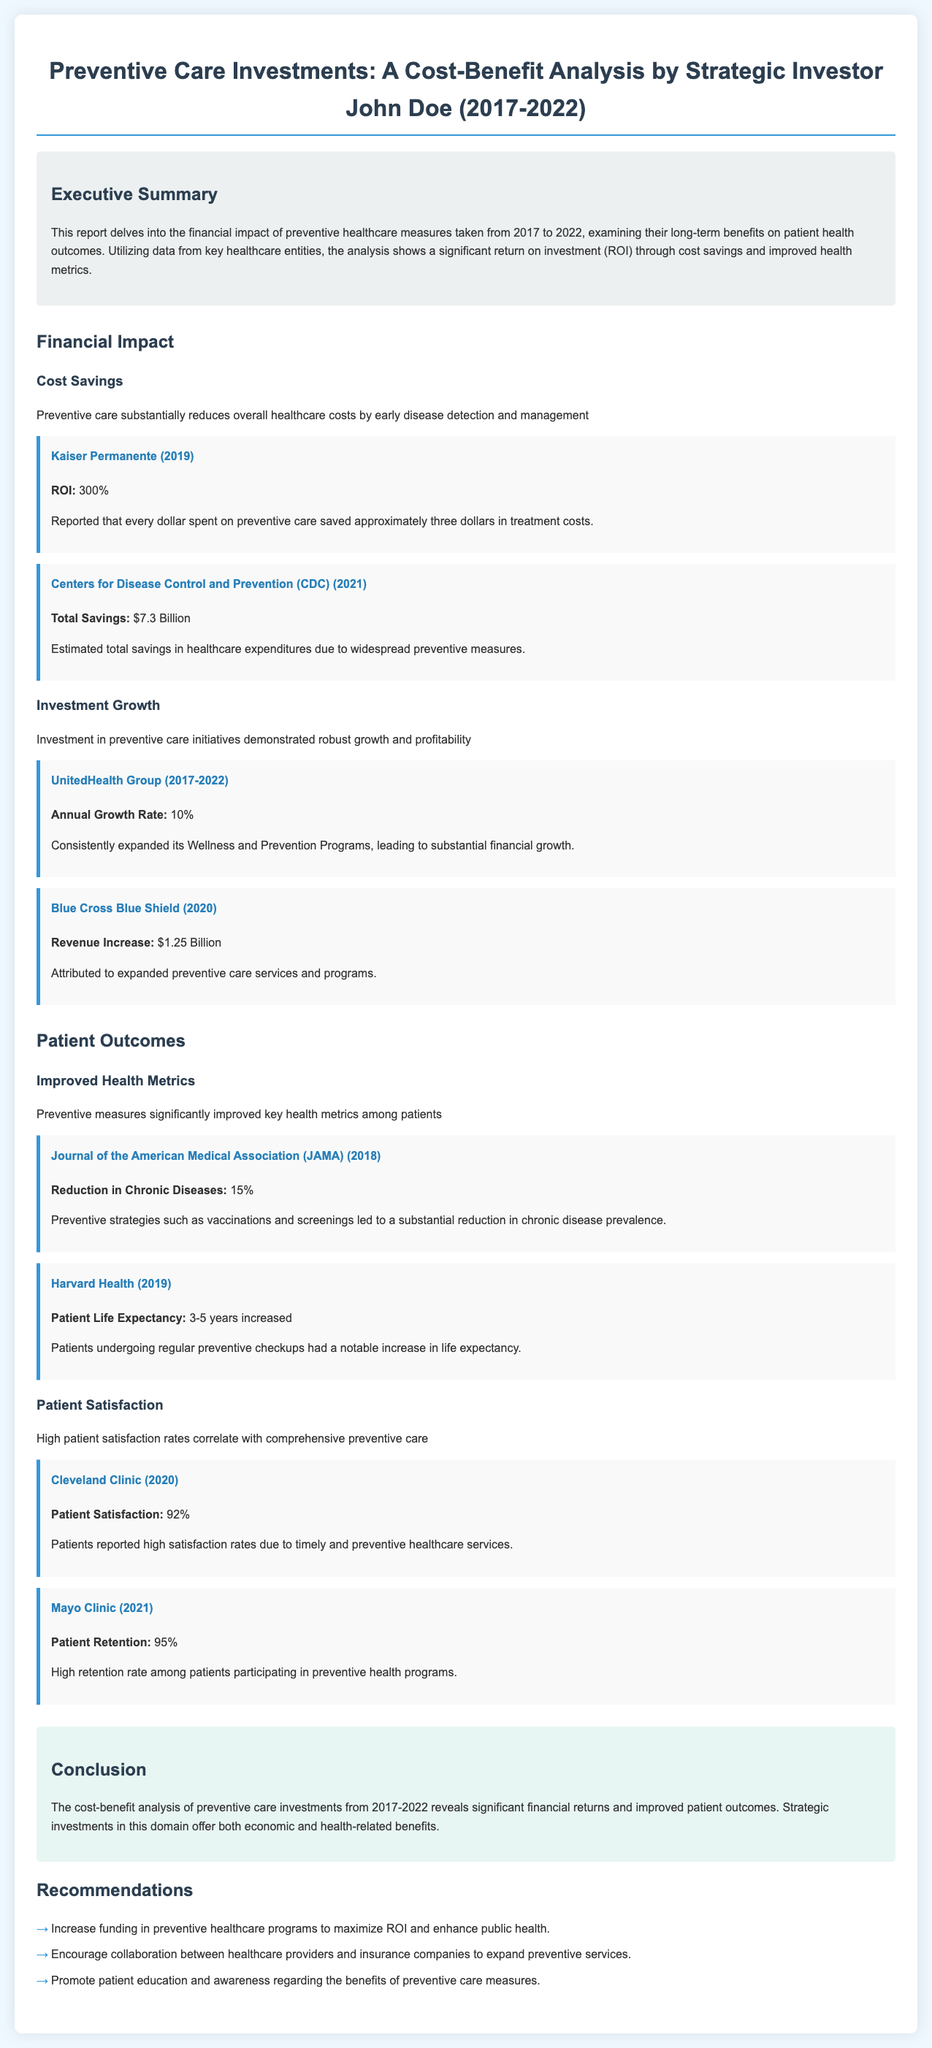What is the ROI reported by Kaiser Permanente? The ROI reported by Kaiser Permanente is the percentage of return on investment from preventive care spending, which is 300%.
Answer: 300% What was the total savings reported by the CDC in 2021? The total savings reported by the CDC in 2021 is an estimation of dollars saved due to preventive measures, which is $7.3 Billion.
Answer: $7.3 Billion What annual growth rate did UnitedHealth Group achieve from 2017 to 2022? The annual growth rate achieved by UnitedHealth Group during this period reflects the increase in their Wellness and Prevention Programs, which is 10%.
Answer: 10% What percentage reduction in chronic diseases does the JAMA report indicate? The report indicates a percentage reduction in chronic diseases due to preventive strategies, which is 15%.
Answer: 15% What was the patient satisfaction rate reported by Cleveland Clinic in 2020? The patient satisfaction rate reported by Cleveland Clinic reflects the percentage of patients satisfied with preventive healthcare services, which is 92%.
Answer: 92% What is one recommendation from the report regarding preventive healthcare funding? The report includes a recommendation focused on enhancing preventive healthcare funding to improve health outcomes and returns, specifically to increase funding.
Answer: Increase funding Which healthcare entity had a revenue increase attributed to preventive care services in 2020? The healthcare entity that reported a revenue increase due to expanded preventive care services is Blue Cross Blue Shield, reflecting a notable financial gain of $1.25 Billion attributed to these services.
Answer: Blue Cross Blue Shield What notable increase in life expectancy was reported by Harvard Health in 2019? Harvard Health reported an increase in life expectancy among patients undergoing regular checkups, measured in years, which is 3-5 years increased.
Answer: 3-5 years increased 